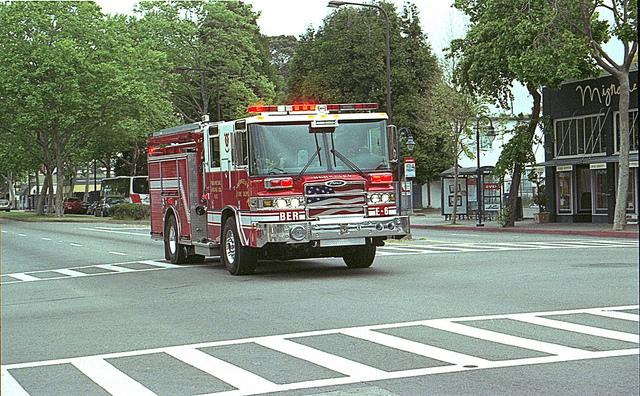What do the flashing lights indicate on this vehicle?

Choices:
A) bad weather
B) fire
C) crime
D) parade fire 